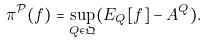<formula> <loc_0><loc_0><loc_500><loc_500>\pi ^ { \mathcal { P } } ( f ) = \sup _ { Q \in \mathfrak { Q } } ( E _ { Q } [ f ] - A ^ { Q } ) .</formula> 